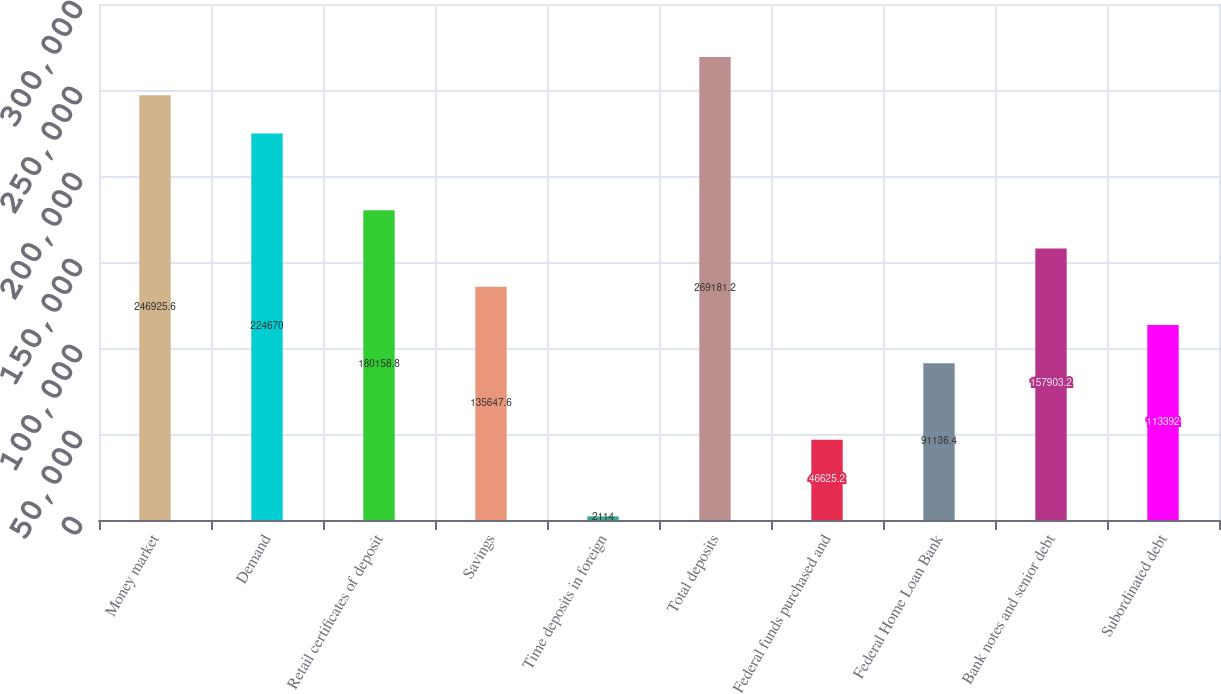Convert chart to OTSL. <chart><loc_0><loc_0><loc_500><loc_500><bar_chart><fcel>Money market<fcel>Demand<fcel>Retail certificates of deposit<fcel>Savings<fcel>Time deposits in foreign<fcel>Total deposits<fcel>Federal funds purchased and<fcel>Federal Home Loan Bank<fcel>Bank notes and senior debt<fcel>Subordinated debt<nl><fcel>246926<fcel>224670<fcel>180159<fcel>135648<fcel>2114<fcel>269181<fcel>46625.2<fcel>91136.4<fcel>157903<fcel>113392<nl></chart> 